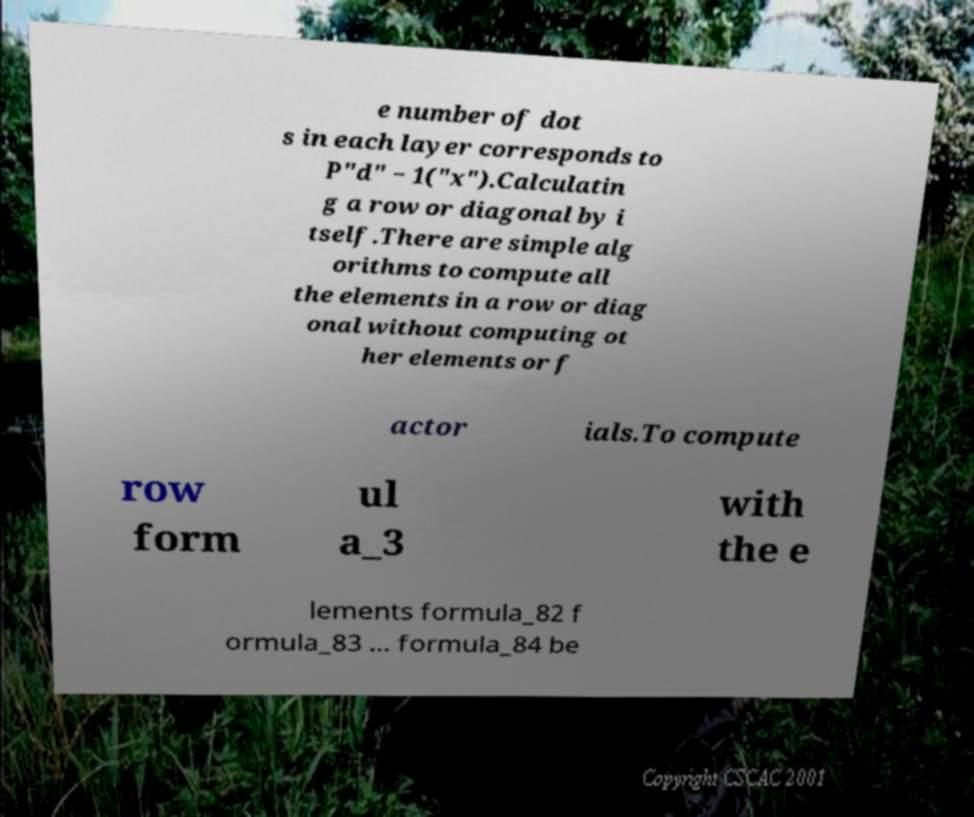Can you read and provide the text displayed in the image?This photo seems to have some interesting text. Can you extract and type it out for me? e number of dot s in each layer corresponds to P"d" − 1("x").Calculatin g a row or diagonal by i tself.There are simple alg orithms to compute all the elements in a row or diag onal without computing ot her elements or f actor ials.To compute row form ul a_3 with the e lements formula_82 f ormula_83 ... formula_84 be 